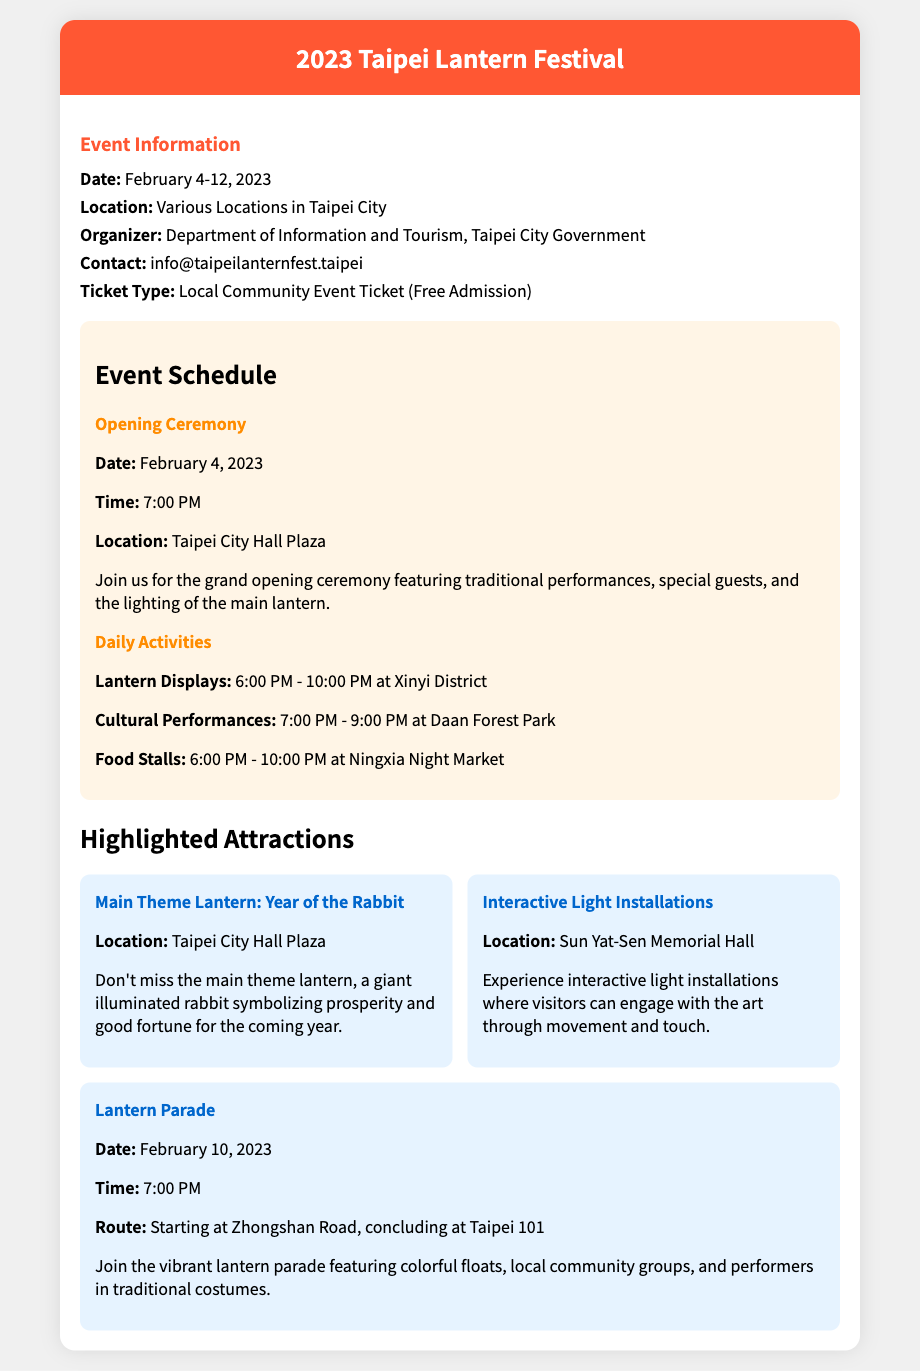What are the event dates? The event dates are clearly stated in the document under Event Information.
Answer: February 4-12, 2023 Where is the opening ceremony taking place? The location for the opening ceremony is mentioned in the schedule section of the document.
Answer: Taipei City Hall Plaza What is the main theme of the lantern? This information can be found in the highlighted attractions section where it describes the main theme lantern.
Answer: Year of the Rabbit What time do the daily lantern displays start? The start time for the daily lantern displays is explicitly listed in the schedule section.
Answer: 6:00 PM On which date does the lantern parade occur? The date of the lantern parade is referenced in the highlighted attractions section of the document.
Answer: February 10, 2023 What is the organizer of the event? The organizer's name is clearly provided in the Event Information part of the document.
Answer: Department of Information and Tourism, Taipei City Government What type of ticket is being offered? This is stated under the ticket information in the document.
Answer: Local Community Event Ticket (Free Admission) What kind of activities can be found at Ningxia Night Market? The type of activities at Ningxia Night Market is mentioned in the daily activities part of the schedule.
Answer: Food Stalls 